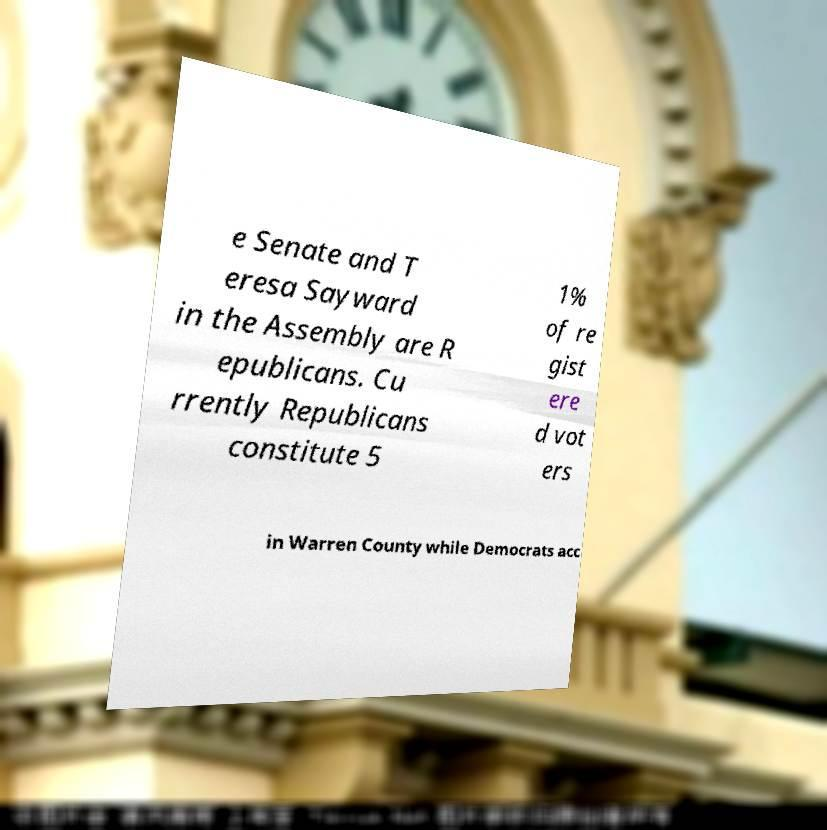Can you read and provide the text displayed in the image?This photo seems to have some interesting text. Can you extract and type it out for me? e Senate and T eresa Sayward in the Assembly are R epublicans. Cu rrently Republicans constitute 5 1% of re gist ere d vot ers in Warren County while Democrats acc 